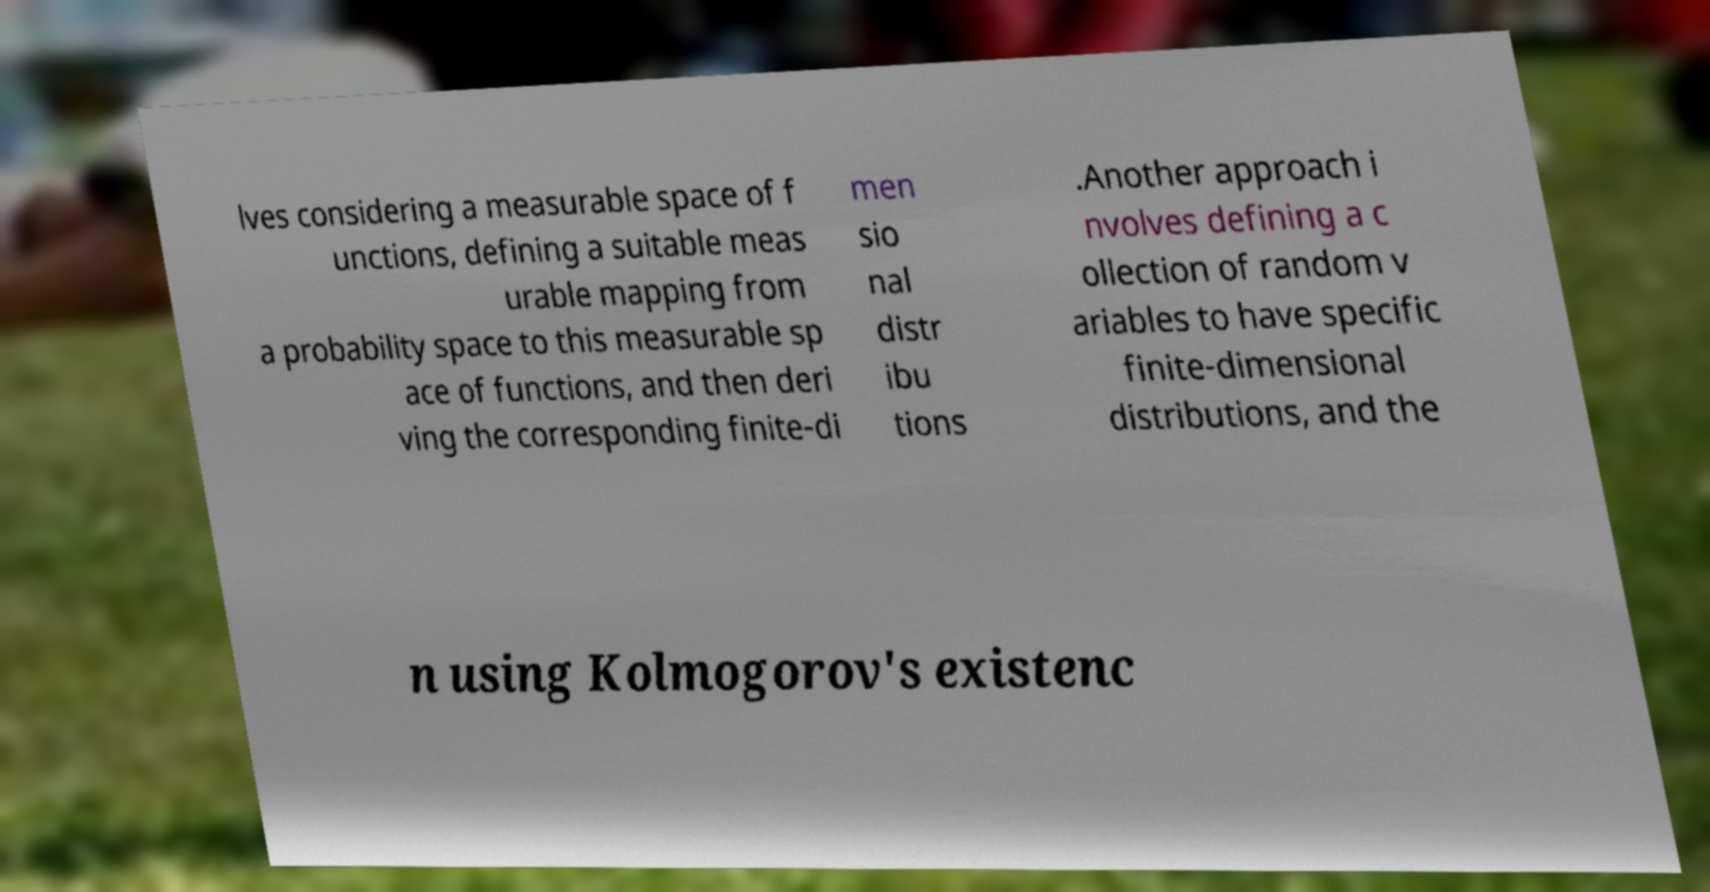I need the written content from this picture converted into text. Can you do that? lves considering a measurable space of f unctions, defining a suitable meas urable mapping from a probability space to this measurable sp ace of functions, and then deri ving the corresponding finite-di men sio nal distr ibu tions .Another approach i nvolves defining a c ollection of random v ariables to have specific finite-dimensional distributions, and the n using Kolmogorov's existenc 